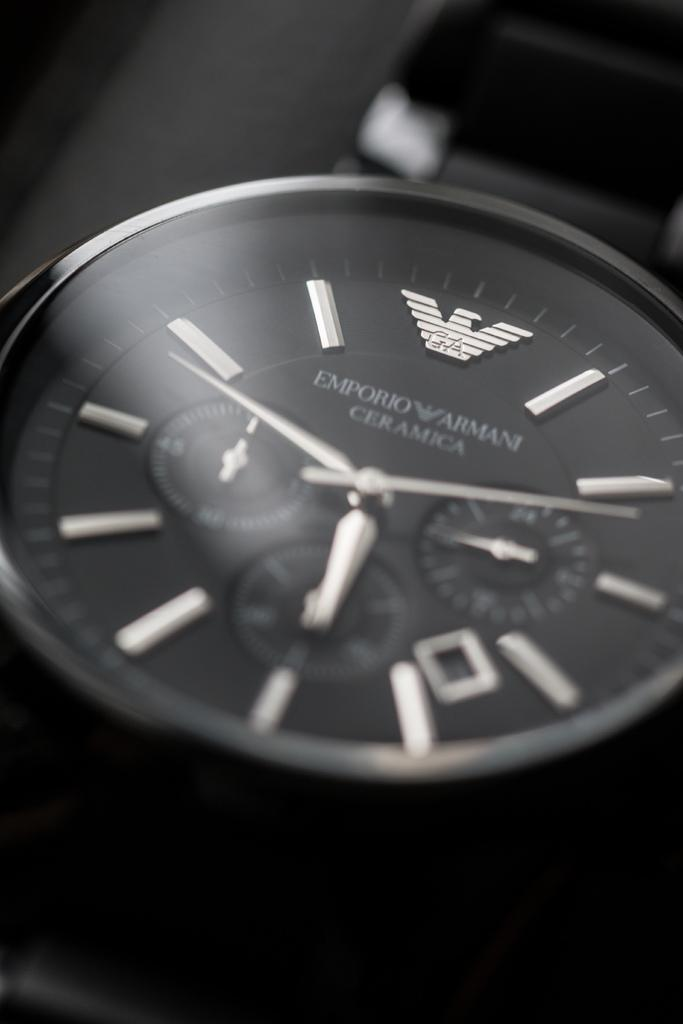<image>
Summarize the visual content of the image. A close up of an Armani watch shows the time as 5:49. 